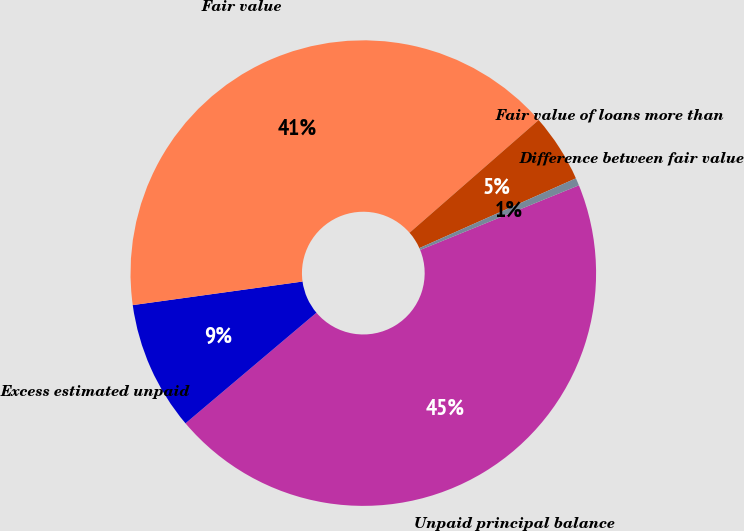<chart> <loc_0><loc_0><loc_500><loc_500><pie_chart><fcel>Unpaid principal balance<fcel>Excess estimated unpaid<fcel>Fair value<fcel>Fair value of loans more than<fcel>Difference between fair value<nl><fcel>44.99%<fcel>8.97%<fcel>40.77%<fcel>4.75%<fcel>0.52%<nl></chart> 